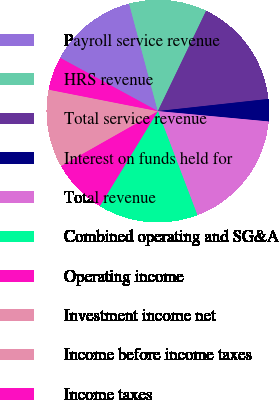<chart> <loc_0><loc_0><loc_500><loc_500><pie_chart><fcel>Payroll service revenue<fcel>HRS revenue<fcel>Total service revenue<fcel>Interest on funds held for<fcel>Total revenue<fcel>Combined operating and SG&A<fcel>Operating income<fcel>Investment income net<fcel>Income before income taxes<fcel>Income taxes<nl><fcel>12.9%<fcel>11.29%<fcel>16.12%<fcel>3.23%<fcel>17.73%<fcel>14.51%<fcel>8.07%<fcel>1.62%<fcel>9.68%<fcel>4.85%<nl></chart> 